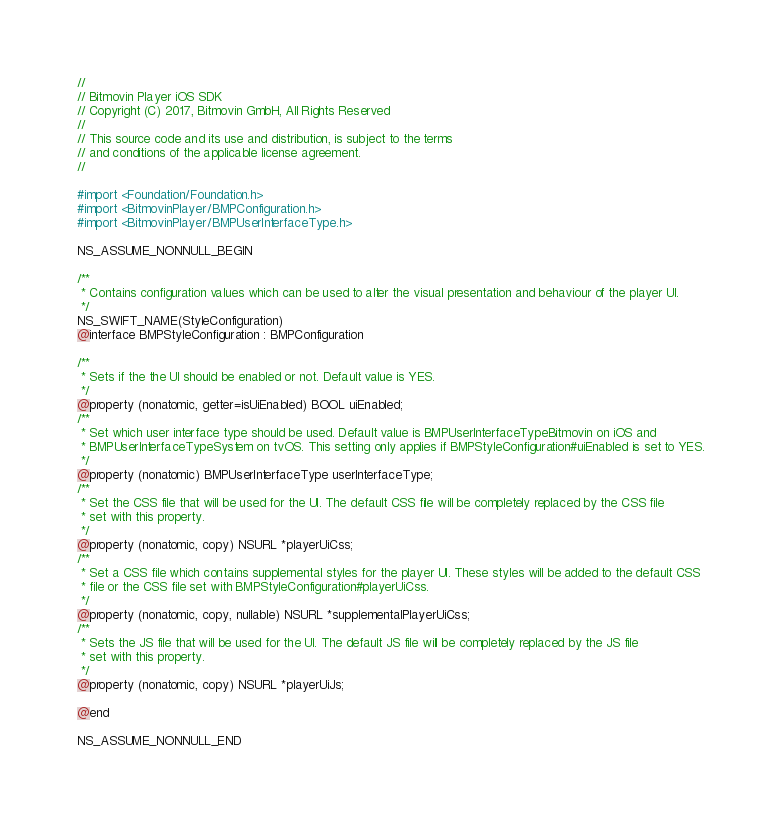<code> <loc_0><loc_0><loc_500><loc_500><_C_>//
// Bitmovin Player iOS SDK
// Copyright (C) 2017, Bitmovin GmbH, All Rights Reserved
//
// This source code and its use and distribution, is subject to the terms
// and conditions of the applicable license agreement.
//

#import <Foundation/Foundation.h>
#import <BitmovinPlayer/BMPConfiguration.h>
#import <BitmovinPlayer/BMPUserInterfaceType.h>

NS_ASSUME_NONNULL_BEGIN

/**
 * Contains configuration values which can be used to alter the visual presentation and behaviour of the player UI.
 */
NS_SWIFT_NAME(StyleConfiguration)
@interface BMPStyleConfiguration : BMPConfiguration

/**
 * Sets if the the UI should be enabled or not. Default value is YES.
 */
@property (nonatomic, getter=isUiEnabled) BOOL uiEnabled;
/**
 * Set which user interface type should be used. Default value is BMPUserInterfaceTypeBitmovin on iOS and
 * BMPUserInterfaceTypeSystem on tvOS. This setting only applies if BMPStyleConfiguration#uiEnabled is set to YES.
 */
@property (nonatomic) BMPUserInterfaceType userInterfaceType;
/**
 * Set the CSS file that will be used for the UI. The default CSS file will be completely replaced by the CSS file
 * set with this property.
 */
@property (nonatomic, copy) NSURL *playerUiCss;
/**
 * Set a CSS file which contains supplemental styles for the player UI. These styles will be added to the default CSS
 * file or the CSS file set with BMPStyleConfiguration#playerUiCss.
 */
@property (nonatomic, copy, nullable) NSURL *supplementalPlayerUiCss;
/**
 * Sets the JS file that will be used for the UI. The default JS file will be completely replaced by the JS file
 * set with this property.
 */
@property (nonatomic, copy) NSURL *playerUiJs;

@end

NS_ASSUME_NONNULL_END
</code> 